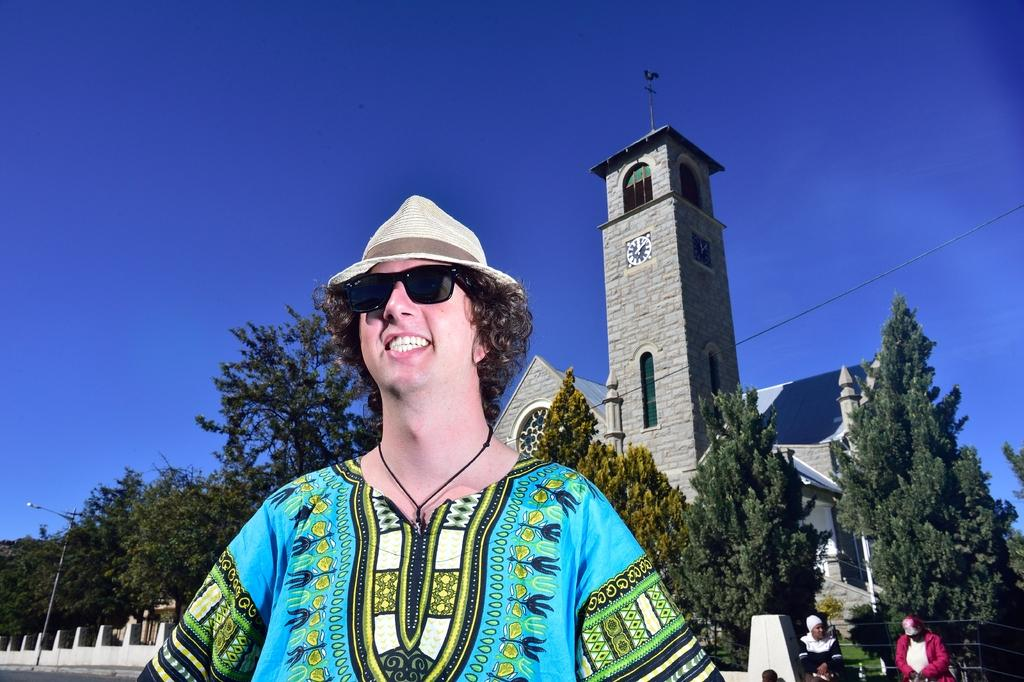Who or what is present in the image? There is a person in the image. What is the person doing? The person is smiling. What can be seen in the background of the image? Trees, a building, a block attached to the wall, a light pole, and people are visible in the background. What is the color of the sky in the image? The sky is blue in the image. What type of drink is the person holding in the image? There is no drink visible in the image; the person is not holding anything. 